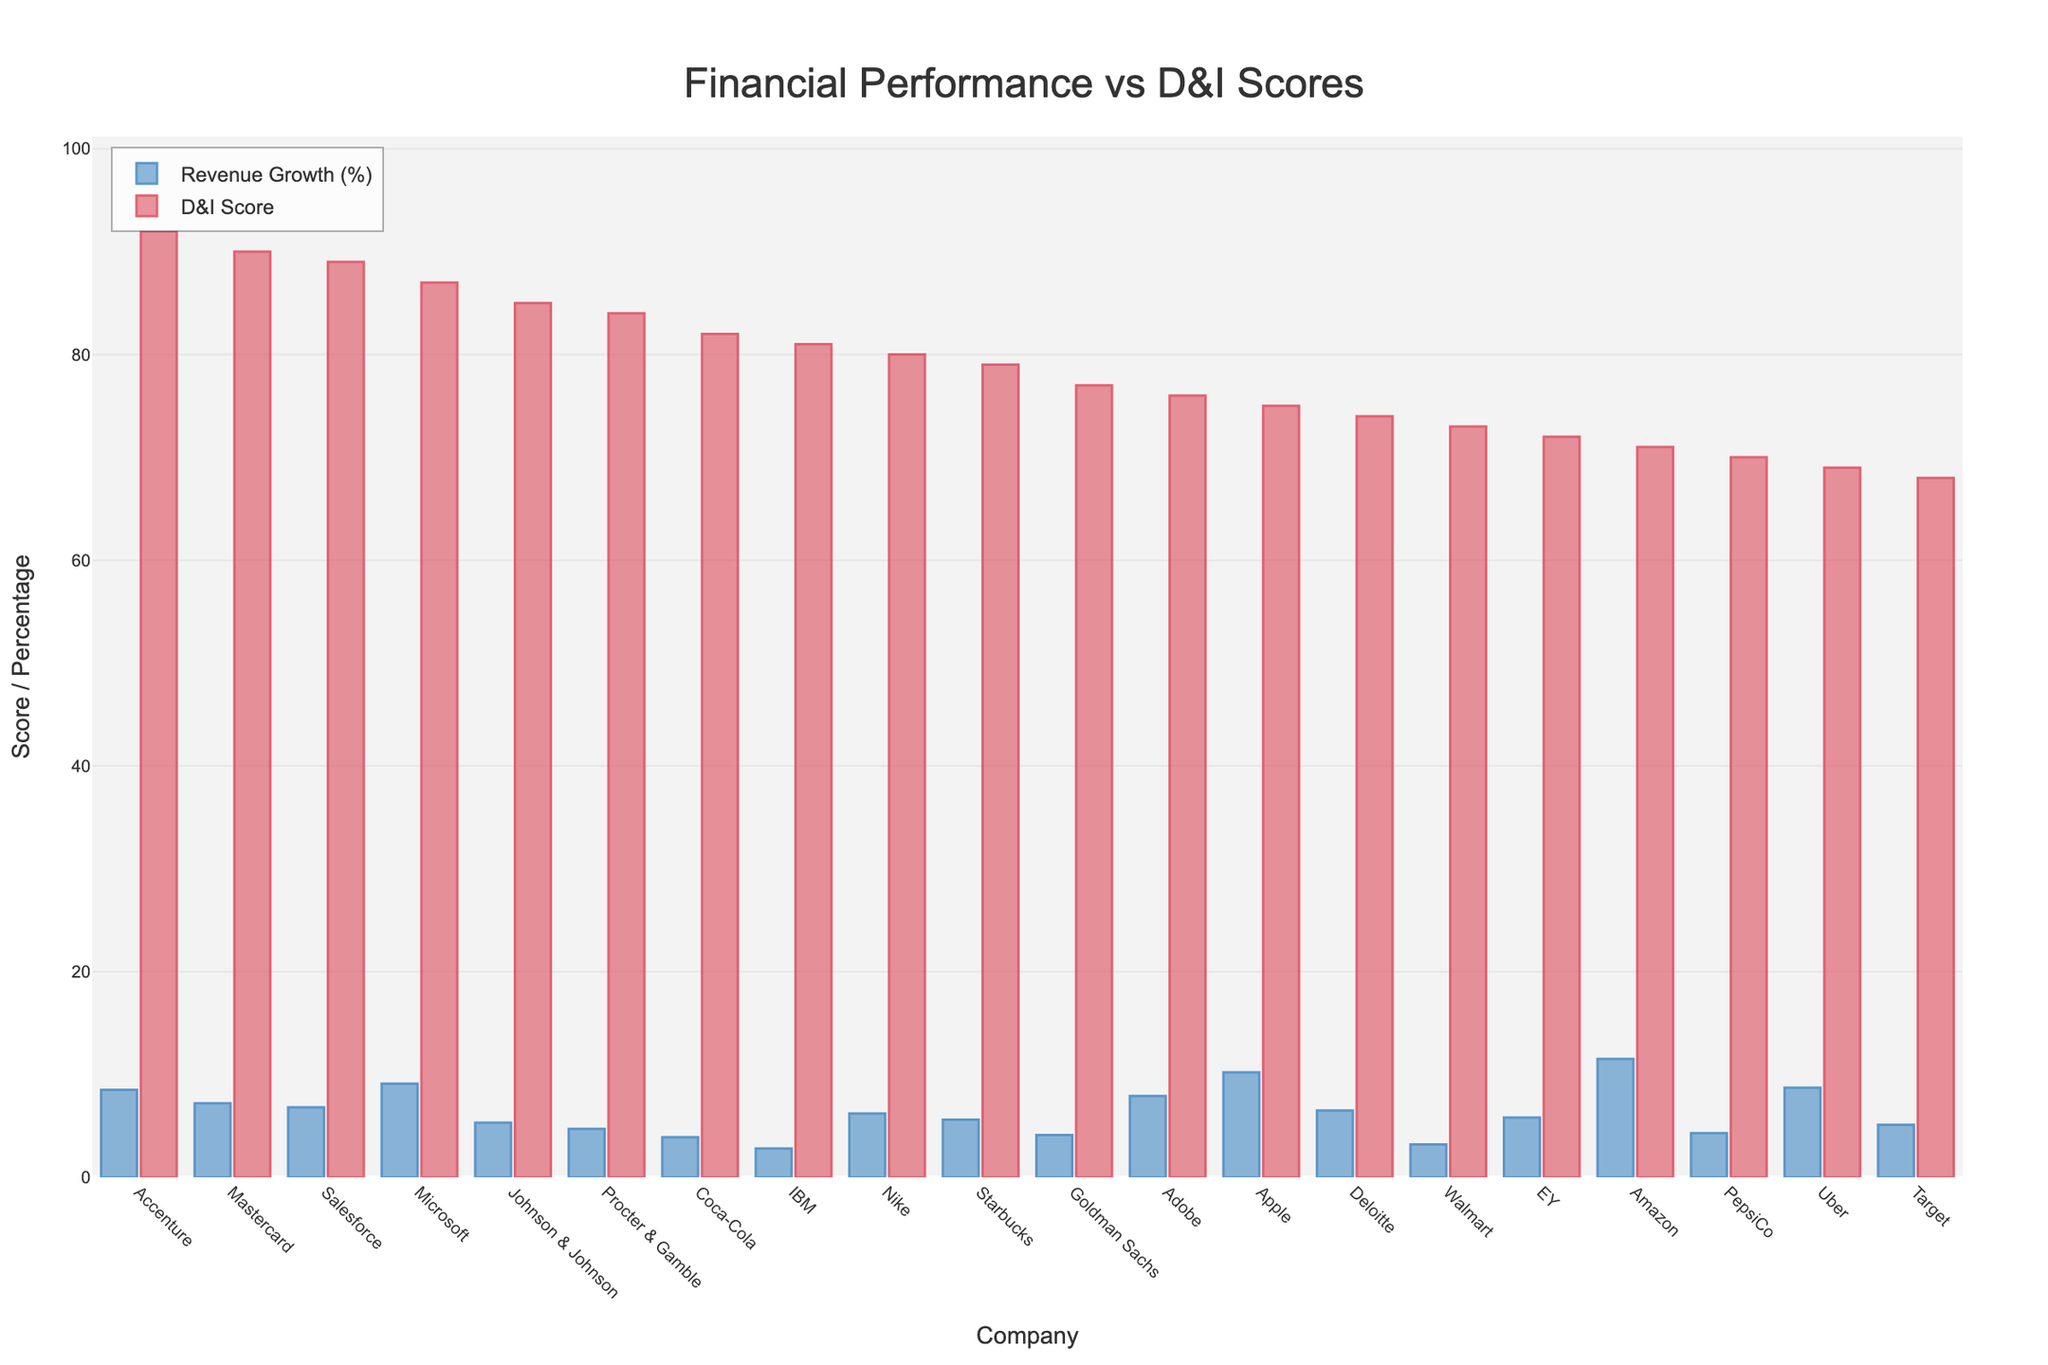Which company has the highest Revenue Growth (%)? By examining the height of the Revenue Growth (%) bars, we can see that Amazon's bar is the tallest, indicating it has the highest Revenue Growth (%)
Answer: Amazon Which company has the lowest D&I Score? By looking at the shortest D&I Score bar, we see Target has the shortest bar, indicating the lowest D&I Score
Answer: Target What is the sum of Revenue Growth (%) for Microsoft and Apple? According to the chart, Microsoft has a Revenue Growth of 9.1% and Apple has 10.2%. Adding these together: 9.1 + 10.2
Answer: 19.3% How does the D&I Score of Procter & Gamble compare to Deloitte? The D&I Score bar for Procter & Gamble is higher than the one for Deloitte, indicating Procter & Gamble has a higher D&I Score
Answer: Procter & Gamble has a higher D&I Score Which two companies have the closest D&I Scores? By closely inspecting the heights of the D&I Score bars, it becomes clear that Accenture and Mastercard have very similar heights, indicating very close D&I Scores of 92 and 90 respectively
Answer: Accenture and Mastercard What is the difference in Revenue Growth between IBM and Salesforce? IBM's Revenue Growth is 2.8% and Salesforce's is 6.8%. Subtracting IBM's value from Salesforce's value gives us: 6.8 - 2.8
Answer: 4.0% How does Nike's Revenue Growth compare to the average Revenue Growth of all companies? To find the average Revenue Growth, sum all the Revenue Growth percentages and divide by the number of companies (i.e., the sum of Revenue Growths divided by 20). Compare Nike's value of 6.2% to this average. The average Revenue Growth is approximately 6.1%, meaning Nike's growth is slightly above average
Answer: Slightly above average Which company has a higher D&I Score, EY or Adobe? The D&I Score bar for EY is slightly shorter than the bar for Adobe, indicating that Adobe has a higher D&I Score
Answer: Adobe What is the average D&I Score of the top three companies by Revenue Growth (%)? The top three companies by Revenue Growth are Amazon (71), Apple (75), and Microsoft (87). Adding their D&I Scores and dividing by 3 gives (71 + 75 + 87) / 3
Answer: 77.67 Is there any company where both Revenue Growth (%) and D&I Score bars have equal height? By visual inspection, there are no companies where the Revenue Growth and D&I Score bars are of equal height
Answer: No 